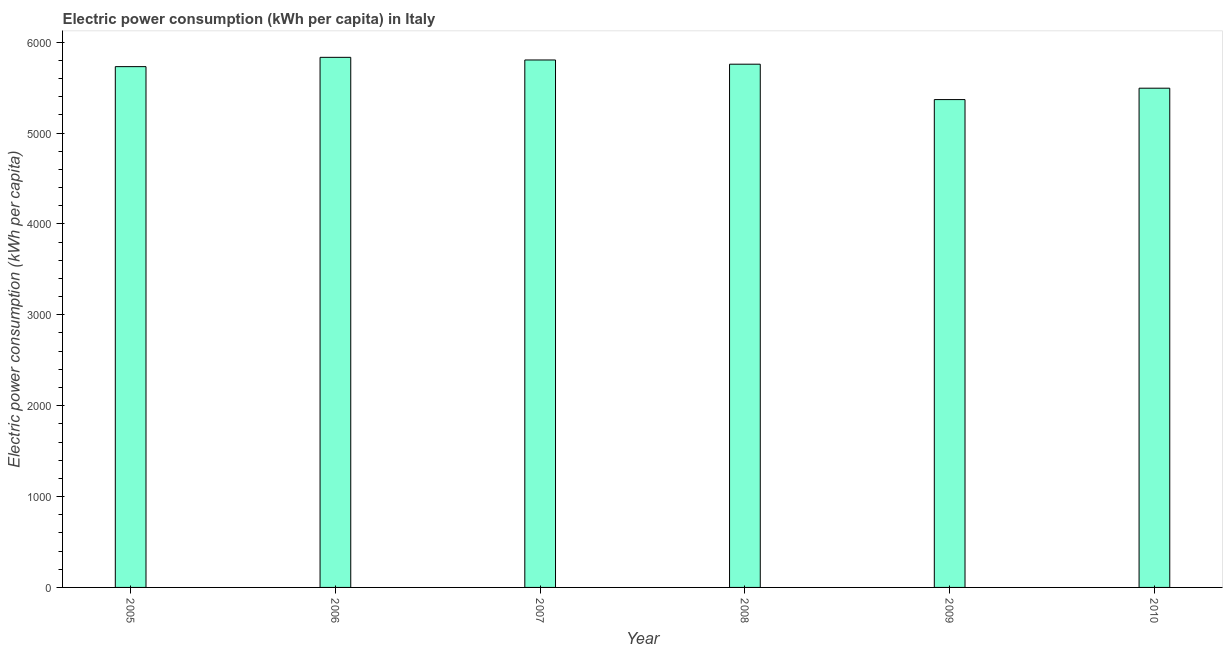What is the title of the graph?
Your answer should be compact. Electric power consumption (kWh per capita) in Italy. What is the label or title of the X-axis?
Provide a short and direct response. Year. What is the label or title of the Y-axis?
Provide a succinct answer. Electric power consumption (kWh per capita). What is the electric power consumption in 2006?
Your response must be concise. 5833.45. Across all years, what is the maximum electric power consumption?
Your response must be concise. 5833.45. Across all years, what is the minimum electric power consumption?
Keep it short and to the point. 5368.41. In which year was the electric power consumption maximum?
Your answer should be compact. 2006. What is the sum of the electric power consumption?
Your answer should be compact. 3.40e+04. What is the difference between the electric power consumption in 2006 and 2008?
Your response must be concise. 75.51. What is the average electric power consumption per year?
Your response must be concise. 5664.82. What is the median electric power consumption?
Ensure brevity in your answer.  5744.51. What is the ratio of the electric power consumption in 2006 to that in 2008?
Your answer should be compact. 1.01. Is the electric power consumption in 2006 less than that in 2010?
Ensure brevity in your answer.  No. Is the difference between the electric power consumption in 2006 and 2007 greater than the difference between any two years?
Offer a very short reply. No. What is the difference between the highest and the second highest electric power consumption?
Offer a terse response. 29.12. What is the difference between the highest and the lowest electric power consumption?
Ensure brevity in your answer.  465.04. How many bars are there?
Your answer should be very brief. 6. Are all the bars in the graph horizontal?
Make the answer very short. No. How many years are there in the graph?
Offer a terse response. 6. Are the values on the major ticks of Y-axis written in scientific E-notation?
Offer a terse response. No. What is the Electric power consumption (kWh per capita) of 2005?
Make the answer very short. 5731.08. What is the Electric power consumption (kWh per capita) of 2006?
Give a very brief answer. 5833.45. What is the Electric power consumption (kWh per capita) in 2007?
Ensure brevity in your answer.  5804.33. What is the Electric power consumption (kWh per capita) in 2008?
Offer a terse response. 5757.94. What is the Electric power consumption (kWh per capita) of 2009?
Offer a terse response. 5368.41. What is the Electric power consumption (kWh per capita) of 2010?
Your answer should be very brief. 5493.73. What is the difference between the Electric power consumption (kWh per capita) in 2005 and 2006?
Your answer should be compact. -102.37. What is the difference between the Electric power consumption (kWh per capita) in 2005 and 2007?
Keep it short and to the point. -73.24. What is the difference between the Electric power consumption (kWh per capita) in 2005 and 2008?
Make the answer very short. -26.86. What is the difference between the Electric power consumption (kWh per capita) in 2005 and 2009?
Keep it short and to the point. 362.68. What is the difference between the Electric power consumption (kWh per capita) in 2005 and 2010?
Provide a short and direct response. 237.36. What is the difference between the Electric power consumption (kWh per capita) in 2006 and 2007?
Offer a very short reply. 29.12. What is the difference between the Electric power consumption (kWh per capita) in 2006 and 2008?
Provide a succinct answer. 75.51. What is the difference between the Electric power consumption (kWh per capita) in 2006 and 2009?
Give a very brief answer. 465.04. What is the difference between the Electric power consumption (kWh per capita) in 2006 and 2010?
Ensure brevity in your answer.  339.72. What is the difference between the Electric power consumption (kWh per capita) in 2007 and 2008?
Offer a very short reply. 46.38. What is the difference between the Electric power consumption (kWh per capita) in 2007 and 2009?
Your answer should be very brief. 435.92. What is the difference between the Electric power consumption (kWh per capita) in 2007 and 2010?
Your response must be concise. 310.6. What is the difference between the Electric power consumption (kWh per capita) in 2008 and 2009?
Keep it short and to the point. 389.54. What is the difference between the Electric power consumption (kWh per capita) in 2008 and 2010?
Ensure brevity in your answer.  264.22. What is the difference between the Electric power consumption (kWh per capita) in 2009 and 2010?
Provide a short and direct response. -125.32. What is the ratio of the Electric power consumption (kWh per capita) in 2005 to that in 2007?
Provide a short and direct response. 0.99. What is the ratio of the Electric power consumption (kWh per capita) in 2005 to that in 2008?
Your answer should be compact. 0.99. What is the ratio of the Electric power consumption (kWh per capita) in 2005 to that in 2009?
Make the answer very short. 1.07. What is the ratio of the Electric power consumption (kWh per capita) in 2005 to that in 2010?
Your response must be concise. 1.04. What is the ratio of the Electric power consumption (kWh per capita) in 2006 to that in 2008?
Your response must be concise. 1.01. What is the ratio of the Electric power consumption (kWh per capita) in 2006 to that in 2009?
Offer a very short reply. 1.09. What is the ratio of the Electric power consumption (kWh per capita) in 2006 to that in 2010?
Provide a succinct answer. 1.06. What is the ratio of the Electric power consumption (kWh per capita) in 2007 to that in 2009?
Offer a terse response. 1.08. What is the ratio of the Electric power consumption (kWh per capita) in 2007 to that in 2010?
Keep it short and to the point. 1.06. What is the ratio of the Electric power consumption (kWh per capita) in 2008 to that in 2009?
Give a very brief answer. 1.07. What is the ratio of the Electric power consumption (kWh per capita) in 2008 to that in 2010?
Your response must be concise. 1.05. What is the ratio of the Electric power consumption (kWh per capita) in 2009 to that in 2010?
Provide a succinct answer. 0.98. 